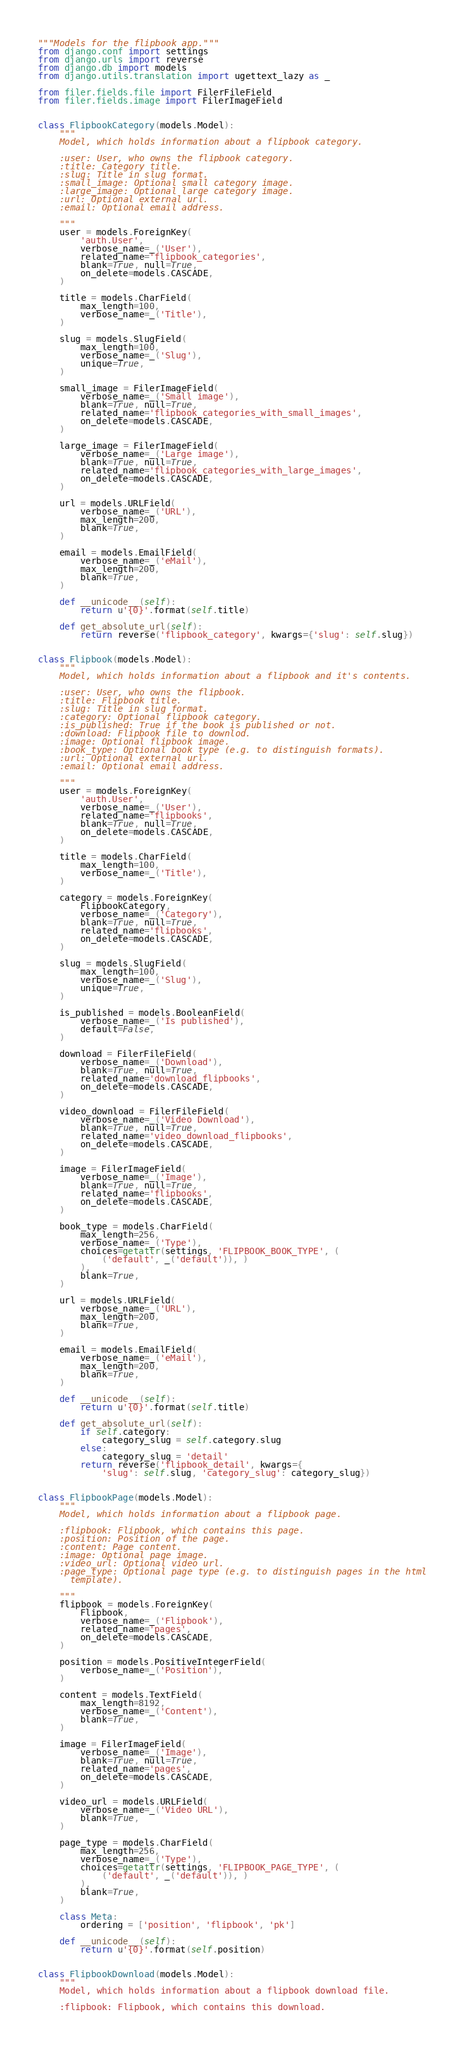<code> <loc_0><loc_0><loc_500><loc_500><_Python_>"""Models for the flipbook app."""
from django.conf import settings
from django.urls import reverse
from django.db import models
from django.utils.translation import ugettext_lazy as _

from filer.fields.file import FilerFileField
from filer.fields.image import FilerImageField


class FlipbookCategory(models.Model):
    """
    Model, which holds information about a flipbook category.

    :user: User, who owns the flipbook category.
    :title: Category title.
    :slug: Title in slug format.
    :small_image: Optional small category image.
    :large_image: Optional large category image.
    :url: Optional external url.
    :email: Optional email address.

    """
    user = models.ForeignKey(
        'auth.User',
        verbose_name=_('User'),
        related_name='flipbook_categories',
        blank=True, null=True,
        on_delete=models.CASCADE,
    )

    title = models.CharField(
        max_length=100,
        verbose_name=_('Title'),
    )

    slug = models.SlugField(
        max_length=100,
        verbose_name=_('Slug'),
        unique=True,
    )

    small_image = FilerImageField(
        verbose_name=_('Small image'),
        blank=True, null=True,
        related_name='flipbook_categories_with_small_images',
        on_delete=models.CASCADE,
    )

    large_image = FilerImageField(
        verbose_name=_('Large image'),
        blank=True, null=True,
        related_name='flipbook_categories_with_large_images',
        on_delete=models.CASCADE,
    )

    url = models.URLField(
        verbose_name=_('URL'),
        max_length=200,
        blank=True,
    )

    email = models.EmailField(
        verbose_name=_('eMail'),
        max_length=200,
        blank=True,
    )

    def __unicode__(self):
        return u'{0}'.format(self.title)

    def get_absolute_url(self):
        return reverse('flipbook_category', kwargs={'slug': self.slug})


class Flipbook(models.Model):
    """
    Model, which holds information about a flipbook and it's contents.

    :user: User, who owns the flipbook.
    :title: Flipbook title.
    :slug: Title in slug format.
    :category: Optional flipbook category.
    :is_published: True if the book is published or not.
    :download: Flipbook file to downlod.
    :image: Optional flipbook image.
    :book_type: Optional book type (e.g. to distinguish formats).
    :url: Optional external url.
    :email: Optional email address.

    """
    user = models.ForeignKey(
        'auth.User',
        verbose_name=_('User'),
        related_name='flipbooks',
        blank=True, null=True,
        on_delete=models.CASCADE,
    )

    title = models.CharField(
        max_length=100,
        verbose_name=_('Title'),
    )

    category = models.ForeignKey(
        FlipbookCategory,
        verbose_name=_('Category'),
        blank=True, null=True,
        related_name='flipbooks',
        on_delete=models.CASCADE,
    )

    slug = models.SlugField(
        max_length=100,
        verbose_name=_('Slug'),
        unique=True,
    )

    is_published = models.BooleanField(
        verbose_name=_('Is published'),
        default=False,
    )

    download = FilerFileField(
        verbose_name=_('Download'),
        blank=True, null=True,
        related_name='download_flipbooks',
        on_delete=models.CASCADE,
    )

    video_download = FilerFileField(
        verbose_name=_('Video Download'),
        blank=True, null=True,
        related_name='video_download_flipbooks',
        on_delete=models.CASCADE,
    )

    image = FilerImageField(
        verbose_name=_('Image'),
        blank=True, null=True,
        related_name='flipbooks',
        on_delete=models.CASCADE,
    )

    book_type = models.CharField(
        max_length=256,
        verbose_name=_('Type'),
        choices=getattr(settings, 'FLIPBOOK_BOOK_TYPE', (
            ('default', _('default')), )
        ),
        blank=True,
    )

    url = models.URLField(
        verbose_name=_('URL'),
        max_length=200,
        blank=True,
    )

    email = models.EmailField(
        verbose_name=_('eMail'),
        max_length=200,
        blank=True,
    )

    def __unicode__(self):
        return u'{0}'.format(self.title)

    def get_absolute_url(self):
        if self.category:
            category_slug = self.category.slug
        else:
            category_slug = 'detail'
        return reverse('flipbook_detail', kwargs={
            'slug': self.slug, 'category_slug': category_slug})


class FlipbookPage(models.Model):
    """
    Model, which holds information about a flipbook page.

    :flipbook: Flipbook, which contains this page.
    :position: Position of the page.
    :content: Page content.
    :image: Optional page image.
    :video_url: Optional video url.
    :page_type: Optional page type (e.g. to distinguish pages in the html
      template).

    """
    flipbook = models.ForeignKey(
        Flipbook,
        verbose_name=_('Flipbook'),
        related_name='pages',
        on_delete=models.CASCADE,
    )

    position = models.PositiveIntegerField(
        verbose_name=_('Position'),
    )

    content = models.TextField(
        max_length=8192,
        verbose_name=_('Content'),
        blank=True,
    )

    image = FilerImageField(
        verbose_name=_('Image'),
        blank=True, null=True,
        related_name='pages',
        on_delete=models.CASCADE,
    )

    video_url = models.URLField(
        verbose_name=_('Video URL'),
        blank=True,
    )

    page_type = models.CharField(
        max_length=256,
        verbose_name=_('Type'),
        choices=getattr(settings, 'FLIPBOOK_PAGE_TYPE', (
            ('default', _('default')), )
        ),
        blank=True,
    )

    class Meta:
        ordering = ['position', 'flipbook', 'pk']

    def __unicode__(self):
        return u'{0}'.format(self.position)


class FlipbookDownload(models.Model):
    """
    Model, which holds information about a flipbook download file.

    :flipbook: Flipbook, which contains this download.</code> 